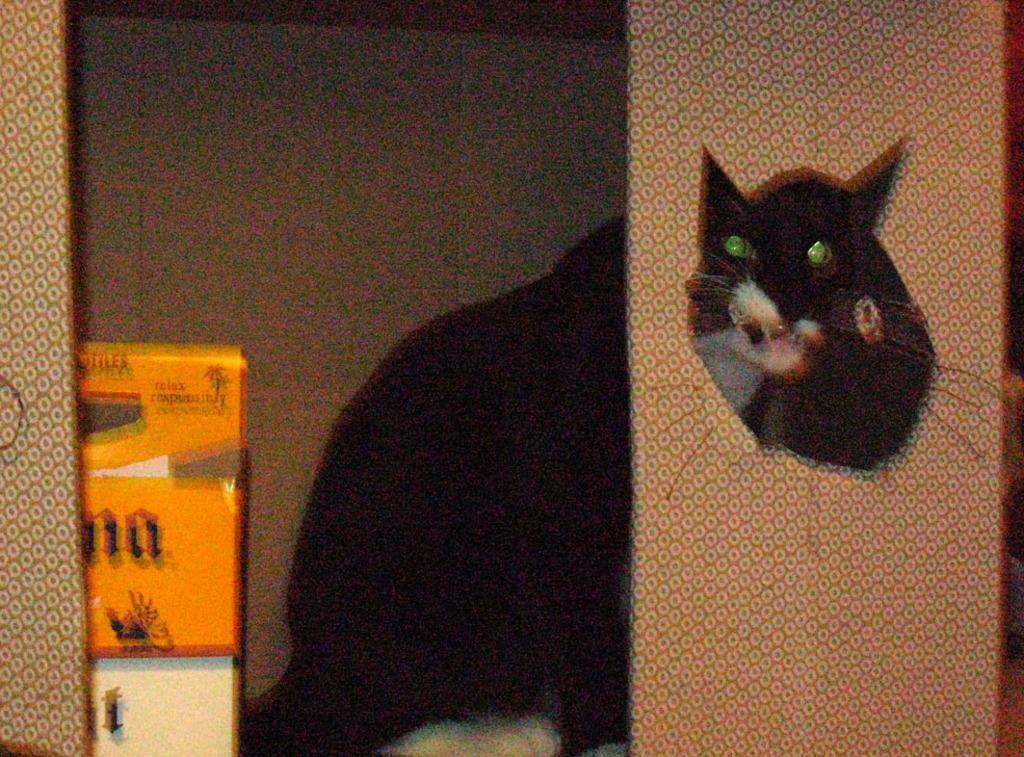Please provide a concise description of this image. In this image we can see a cardboard sheet, a cat and few objects beside the cat and it looks like a wall in the background. 